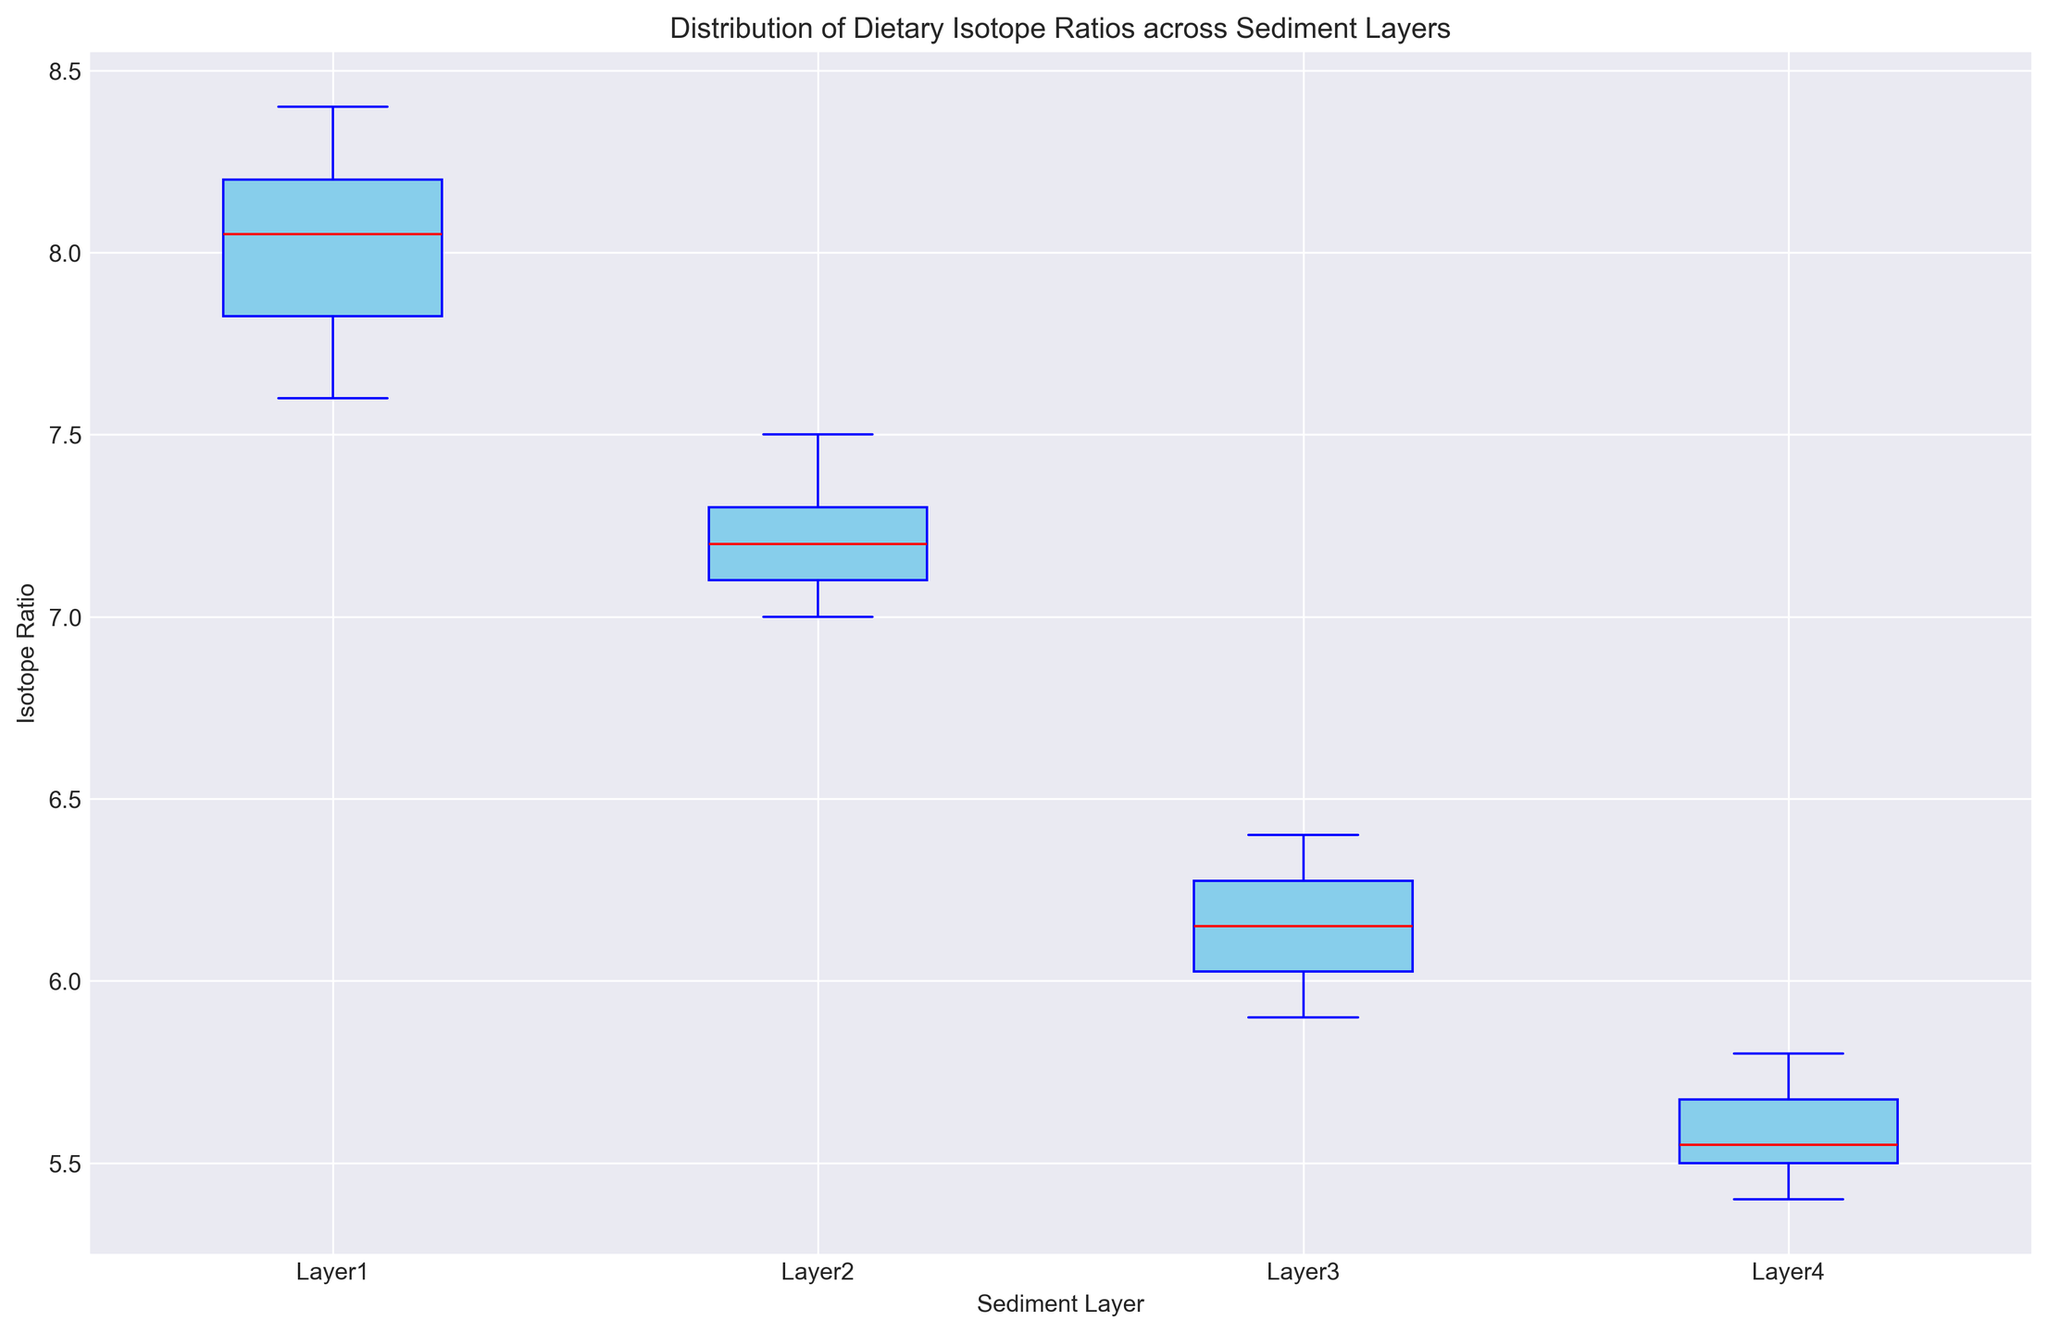Which sediment layer has the highest median isotope ratio? By looking at the box plot, observe the red line inside the boxes which indicates the median value for each layer. The box plot shows that Layer 1 has the highest median isotope ratio.
Answer: Layer 1 Which layer shows the biggest range in isotope ratios? The range in a box plot is given by the distance between the minimum and maximum whiskers. Observing the figure, Layer 1 has the longest distance between its whiskers, indicating the largest range in isotope ratios.
Answer: Layer 1 How do the interquartile ranges (IQR) of Layer 2 and Layer 3 compare? The interquartile range (IQR) is the length of the box, representing the range between the first quartile (Q1) and the third quartile (Q3). By comparing the lengths of the boxes for Layer 2 and Layer 3, we see that Layer 3 has a slightly larger IQR than Layer 2.
Answer: Layer 3 has a slightly larger IQR What is the median isotope ratio in Layer 4? The median is indicated by the red line inside the blue box for each layer. For Layer 4, the median isotope ratio is 5.5.
Answer: 5.5 Which layer has the lower bound of its interquartile range closest to 7.0? The lower bound of the interquartile range (Q1) is where the box begins. Observing Layer 2, its lower bound (Q1) is closest to 7.0.
Answer: Layer 2 Is there any overlap between the interquartile ranges of Layer 1 and Layer 2? To determine the overlap, observe the extent of the boxes (IQR) for Layer 1 and Layer 2. The top part of Layer 2's box overlaps with the lower part of Layer 1's box.
Answer: Yes What is the middle value of the isotope ratio range in Layer 3? The middle value of the range (median) for Layer 3 is shown by the red line inside its box, which is approximately 6.2.
Answer: 6.2 How does the whisker length of Layer 4 compare to that of Layer 3? The whisker length can be seen as the distance between the top of the box and the top whisker plus the distance between the bottom of the box and the bottom whisker. Comparing both layers, Layer 4 has shorter whiskers than Layer 3.
Answer: Layer 4 has shorter whiskers Which layer shows the least variation in isotope ratios? The variation is shown by the spread of the box and whiskers. Layer 4 has the shortest box and whiskers, indicating the least variation in isotope ratios.
Answer: Layer 4 Which sediment layer's upper whisker extends to the lowest value? The upper whisker is the top line extending from the box. Observing the figure, Layer 4's upper whisker extends to the lowest value compared to the others.
Answer: Layer 4 